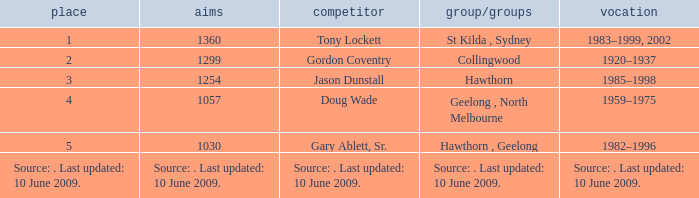Which player has 1299 goals? Gordon Coventry. 